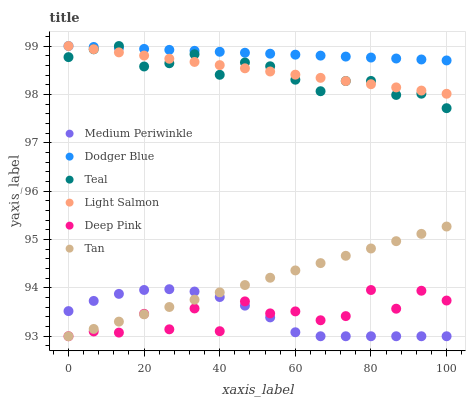Does Medium Periwinkle have the minimum area under the curve?
Answer yes or no. Yes. Does Dodger Blue have the maximum area under the curve?
Answer yes or no. Yes. Does Deep Pink have the minimum area under the curve?
Answer yes or no. No. Does Deep Pink have the maximum area under the curve?
Answer yes or no. No. Is Dodger Blue the smoothest?
Answer yes or no. Yes. Is Deep Pink the roughest?
Answer yes or no. Yes. Is Medium Periwinkle the smoothest?
Answer yes or no. No. Is Medium Periwinkle the roughest?
Answer yes or no. No. Does Deep Pink have the lowest value?
Answer yes or no. Yes. Does Dodger Blue have the lowest value?
Answer yes or no. No. Does Teal have the highest value?
Answer yes or no. Yes. Does Medium Periwinkle have the highest value?
Answer yes or no. No. Is Tan less than Dodger Blue?
Answer yes or no. Yes. Is Light Salmon greater than Medium Periwinkle?
Answer yes or no. Yes. Does Deep Pink intersect Tan?
Answer yes or no. Yes. Is Deep Pink less than Tan?
Answer yes or no. No. Is Deep Pink greater than Tan?
Answer yes or no. No. Does Tan intersect Dodger Blue?
Answer yes or no. No. 